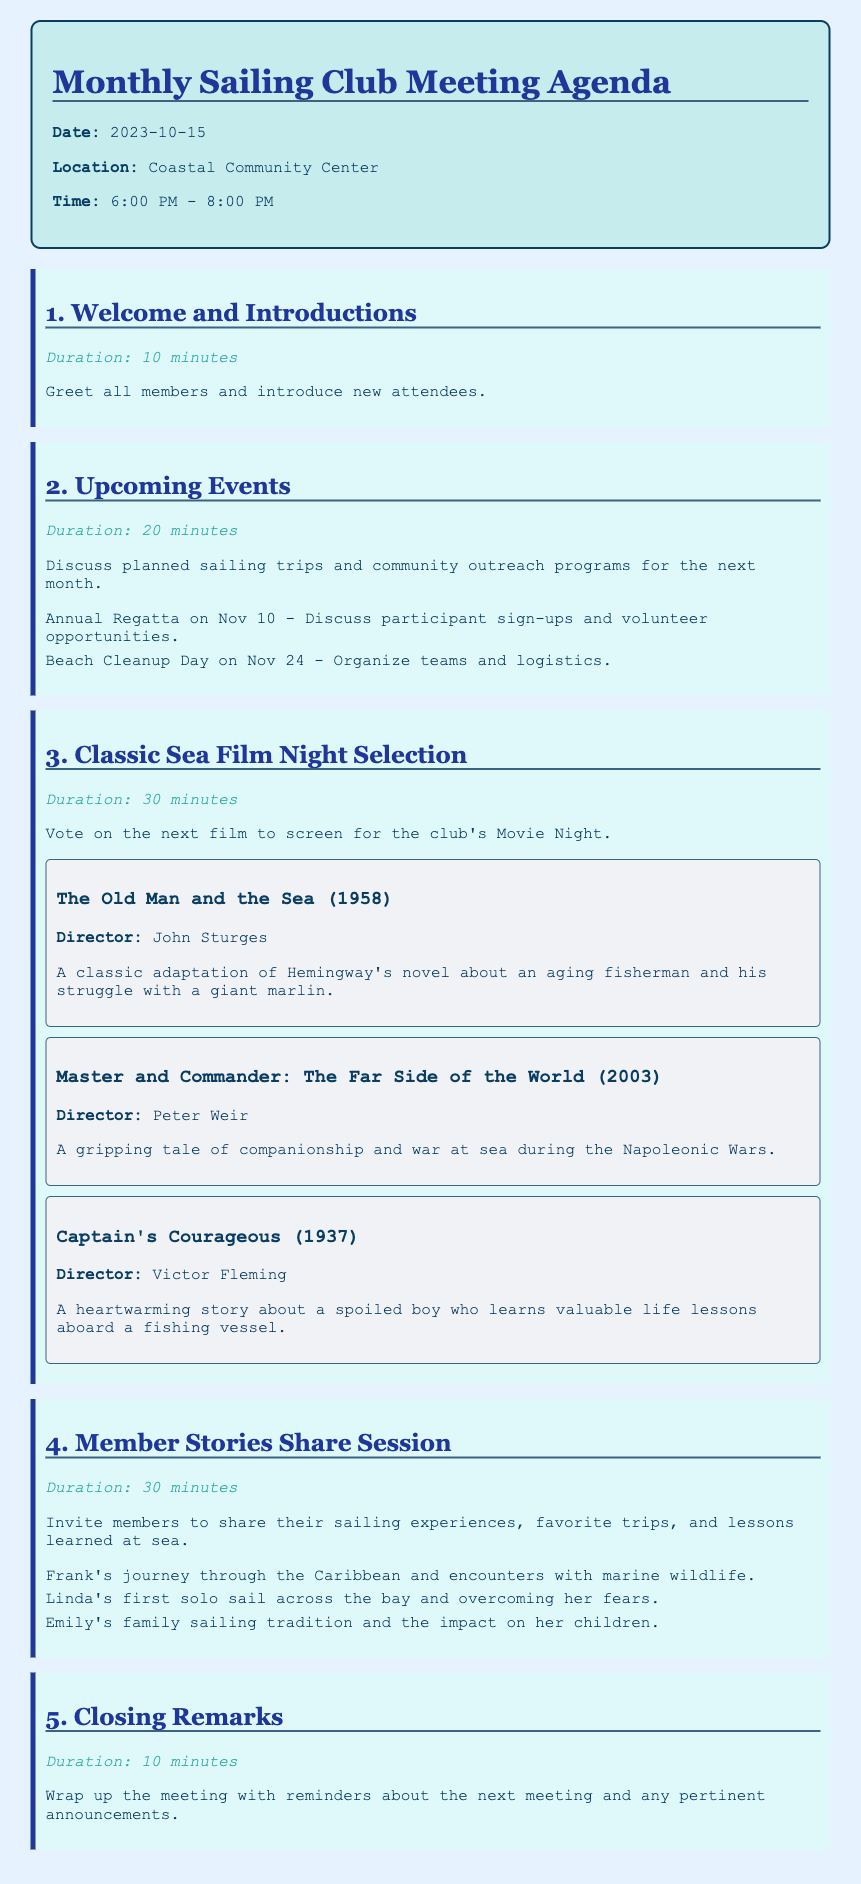What is the date of the meeting? The date can be found in the header of the document, which states "Date: 2023-10-15".
Answer: 2023-10-15 Where will the meeting be held? The location is specified in the header, showing "Location: Coastal Community Center".
Answer: Coastal Community Center What is the duration of the Welcome and Introductions section? The duration for this agenda item is specified in the document as "Duration: 10 minutes".
Answer: 10 minutes Which film is directed by John Sturges? The film option includes details about directors, and it states that "The Old Man and the Sea (1958)" is directed by John Sturges.
Answer: The Old Man and the Sea (1958) How many minutes are allocated for the Member Stories Share Session? The document specifies the duration for this section as "Duration: 30 minutes".
Answer: 30 minutes What specific community outreach program is mentioned for November? The upcoming events section lists "Beach Cleanup Day on Nov 24" as a community outreach program.
Answer: Beach Cleanup Day on Nov 24 Which film involves a journey during the Napoleonic Wars? The film options detail include that "Master and Commander: The Far Side of the World" relates to the Napoleonic Wars.
Answer: Master and Commander: The Far Side of the World What is the main topic of the 5th agenda item? The document outlines the last item as "Closing Remarks," indicating its main focus.
Answer: Closing Remarks 